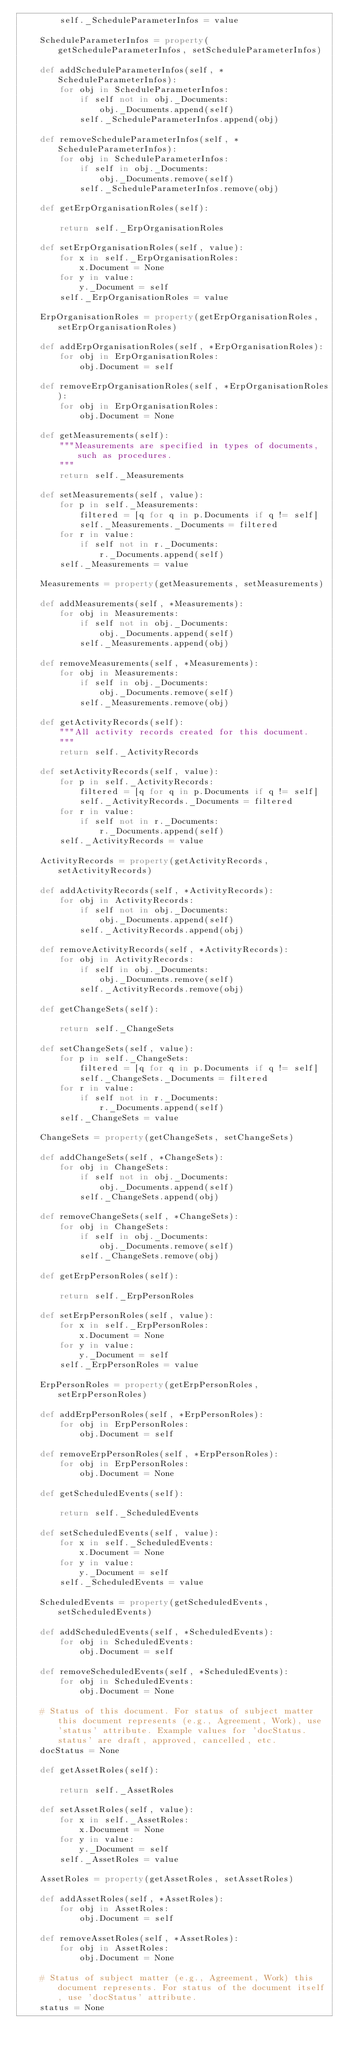Convert code to text. <code><loc_0><loc_0><loc_500><loc_500><_Python_>        self._ScheduleParameterInfos = value

    ScheduleParameterInfos = property(getScheduleParameterInfos, setScheduleParameterInfos)

    def addScheduleParameterInfos(self, *ScheduleParameterInfos):
        for obj in ScheduleParameterInfos:
            if self not in obj._Documents:
                obj._Documents.append(self)
            self._ScheduleParameterInfos.append(obj)

    def removeScheduleParameterInfos(self, *ScheduleParameterInfos):
        for obj in ScheduleParameterInfos:
            if self in obj._Documents:
                obj._Documents.remove(self)
            self._ScheduleParameterInfos.remove(obj)

    def getErpOrganisationRoles(self):
        
        return self._ErpOrganisationRoles

    def setErpOrganisationRoles(self, value):
        for x in self._ErpOrganisationRoles:
            x.Document = None
        for y in value:
            y._Document = self
        self._ErpOrganisationRoles = value

    ErpOrganisationRoles = property(getErpOrganisationRoles, setErpOrganisationRoles)

    def addErpOrganisationRoles(self, *ErpOrganisationRoles):
        for obj in ErpOrganisationRoles:
            obj.Document = self

    def removeErpOrganisationRoles(self, *ErpOrganisationRoles):
        for obj in ErpOrganisationRoles:
            obj.Document = None

    def getMeasurements(self):
        """Measurements are specified in types of documents, such as procedures.
        """
        return self._Measurements

    def setMeasurements(self, value):
        for p in self._Measurements:
            filtered = [q for q in p.Documents if q != self]
            self._Measurements._Documents = filtered
        for r in value:
            if self not in r._Documents:
                r._Documents.append(self)
        self._Measurements = value

    Measurements = property(getMeasurements, setMeasurements)

    def addMeasurements(self, *Measurements):
        for obj in Measurements:
            if self not in obj._Documents:
                obj._Documents.append(self)
            self._Measurements.append(obj)

    def removeMeasurements(self, *Measurements):
        for obj in Measurements:
            if self in obj._Documents:
                obj._Documents.remove(self)
            self._Measurements.remove(obj)

    def getActivityRecords(self):
        """All activity records created for this document.
        """
        return self._ActivityRecords

    def setActivityRecords(self, value):
        for p in self._ActivityRecords:
            filtered = [q for q in p.Documents if q != self]
            self._ActivityRecords._Documents = filtered
        for r in value:
            if self not in r._Documents:
                r._Documents.append(self)
        self._ActivityRecords = value

    ActivityRecords = property(getActivityRecords, setActivityRecords)

    def addActivityRecords(self, *ActivityRecords):
        for obj in ActivityRecords:
            if self not in obj._Documents:
                obj._Documents.append(self)
            self._ActivityRecords.append(obj)

    def removeActivityRecords(self, *ActivityRecords):
        for obj in ActivityRecords:
            if self in obj._Documents:
                obj._Documents.remove(self)
            self._ActivityRecords.remove(obj)

    def getChangeSets(self):
        
        return self._ChangeSets

    def setChangeSets(self, value):
        for p in self._ChangeSets:
            filtered = [q for q in p.Documents if q != self]
            self._ChangeSets._Documents = filtered
        for r in value:
            if self not in r._Documents:
                r._Documents.append(self)
        self._ChangeSets = value

    ChangeSets = property(getChangeSets, setChangeSets)

    def addChangeSets(self, *ChangeSets):
        for obj in ChangeSets:
            if self not in obj._Documents:
                obj._Documents.append(self)
            self._ChangeSets.append(obj)

    def removeChangeSets(self, *ChangeSets):
        for obj in ChangeSets:
            if self in obj._Documents:
                obj._Documents.remove(self)
            self._ChangeSets.remove(obj)

    def getErpPersonRoles(self):
        
        return self._ErpPersonRoles

    def setErpPersonRoles(self, value):
        for x in self._ErpPersonRoles:
            x.Document = None
        for y in value:
            y._Document = self
        self._ErpPersonRoles = value

    ErpPersonRoles = property(getErpPersonRoles, setErpPersonRoles)

    def addErpPersonRoles(self, *ErpPersonRoles):
        for obj in ErpPersonRoles:
            obj.Document = self

    def removeErpPersonRoles(self, *ErpPersonRoles):
        for obj in ErpPersonRoles:
            obj.Document = None

    def getScheduledEvents(self):
        
        return self._ScheduledEvents

    def setScheduledEvents(self, value):
        for x in self._ScheduledEvents:
            x.Document = None
        for y in value:
            y._Document = self
        self._ScheduledEvents = value

    ScheduledEvents = property(getScheduledEvents, setScheduledEvents)

    def addScheduledEvents(self, *ScheduledEvents):
        for obj in ScheduledEvents:
            obj.Document = self

    def removeScheduledEvents(self, *ScheduledEvents):
        for obj in ScheduledEvents:
            obj.Document = None

    # Status of this document. For status of subject matter this document represents (e.g., Agreement, Work), use 'status' attribute. Example values for 'docStatus.status' are draft, approved, cancelled, etc.
    docStatus = None

    def getAssetRoles(self):
        
        return self._AssetRoles

    def setAssetRoles(self, value):
        for x in self._AssetRoles:
            x.Document = None
        for y in value:
            y._Document = self
        self._AssetRoles = value

    AssetRoles = property(getAssetRoles, setAssetRoles)

    def addAssetRoles(self, *AssetRoles):
        for obj in AssetRoles:
            obj.Document = self

    def removeAssetRoles(self, *AssetRoles):
        for obj in AssetRoles:
            obj.Document = None

    # Status of subject matter (e.g., Agreement, Work) this document represents. For status of the document itself, use 'docStatus' attribute.
    status = None
</code> 